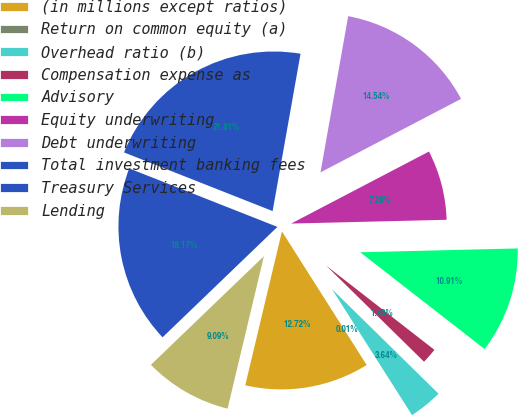<chart> <loc_0><loc_0><loc_500><loc_500><pie_chart><fcel>(in millions except ratios)<fcel>Return on common equity (a)<fcel>Overhead ratio (b)<fcel>Compensation expense as<fcel>Advisory<fcel>Equity underwriting<fcel>Debt underwriting<fcel>Total investment banking fees<fcel>Treasury Services<fcel>Lending<nl><fcel>12.72%<fcel>0.01%<fcel>3.64%<fcel>1.83%<fcel>10.91%<fcel>7.28%<fcel>14.54%<fcel>21.81%<fcel>18.17%<fcel>9.09%<nl></chart> 